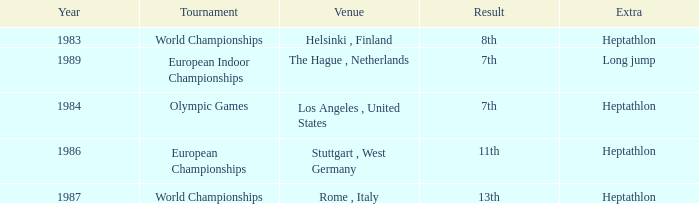How often are the Olympic games hosted? 1984.0. 